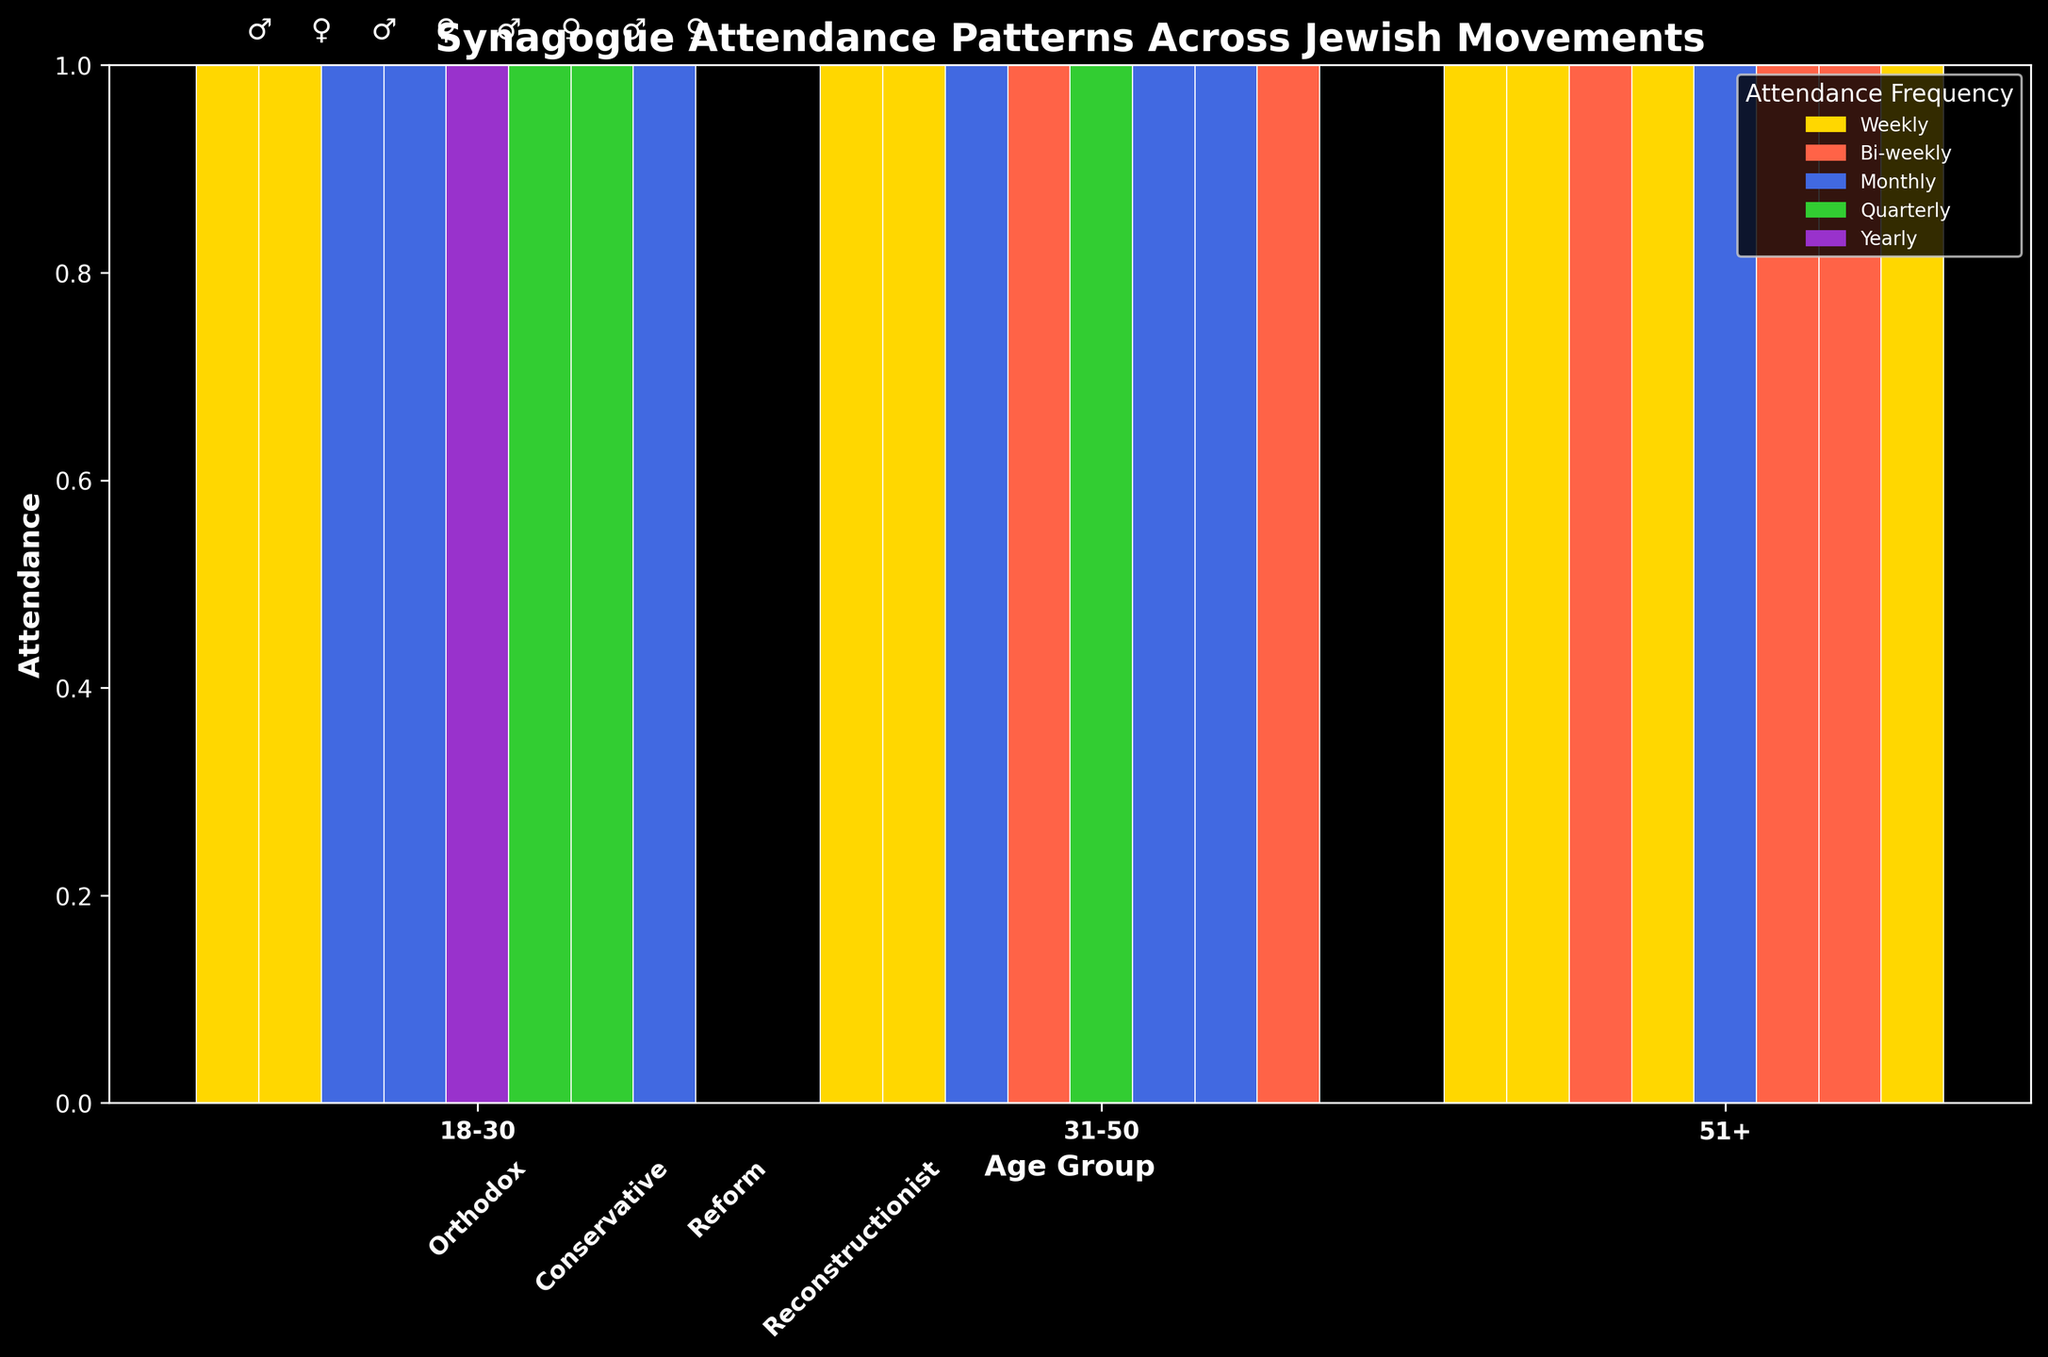What age group has the highest weekly attendance in the Orthodox movement for males? Look at the weekly attendance for males across age groups within the Orthodox section. The tallest bar in the male section (indicated by the symbol '♂') within Orthodox for weekly attendance corresponds to the 18-30 age group.
Answer: 18-30 Which movement has the most frequent quarterly attendance for females aged 18-30? Examine the 18-30 age group section for females (indicated by the symbol '♀') and identify which movement has the color assigned to quarterly attendance. The highest bar in the 18-30 female group with the color for quarterly attendance is found in the Reform movement.
Answer: Reform Compare monthly attendance between males and females aged 31-50 in the Conservative movement. Who attends more? Within the Conservative section for the 31-50 age group, compare the heights of the bars corresponding to monthly attendance. The male bar (♂) and the female bar (♀). The female bar is lower than the male bar, indicating that males attend more frequently in this category.
Answer: Males What is the attendance pattern for people aged 51+ in the Reconstructionist movement? Look at the 51+ age group within the Reconstructionist section and observe the bar heights and colors. Females attend weekly, while males attend bi-weekly and monthly (both bars have similar heights for these frequencies).
Answer: Females: Weekly, Males: Bi-weekly, Monthly Which age and gender group has the least frequent (yearly) attendance in the Reform movement? Find the bar with the color representing yearly attendance in the Reform section. The only bar for yearly attendance in the Reform section is for males aged 18-30.
Answer: Males aged 18-30 How does the bi-weekly attendance frequency differ between males aged 31-50 in the Conservative and Reconstructionist movements? Compare the heights of the bars representing bi-weekly attendance for males aged 31-50 in both movements. The Conservative bar appears shorter than the Reconstructionist bar, indicating fewer attendees.
Answer: Conservative < Reconstructionist Which movement shows the most balanced synagogue attendance between genders for the 18-30 age group? Compare bar heights for males (♂) and females (♀) within the 18-30 age group across all movements. In the Orthodox section, the male and female bars for weekly attendance are roughly equal in height.
Answer: Orthodox What is the most common attendance frequency for females aged 51+ in the Conservative and Reconstructionist movements? In the 51+ age group, check which attendance frequency has the highest bar for females (♀) in both Conservative and Reconstructionist movements. In Conservative, it's weekly; in Reconstructionist, it's also weekly.
Answer: Weekly 